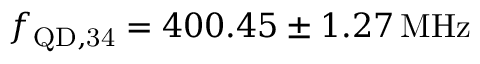<formula> <loc_0><loc_0><loc_500><loc_500>f _ { Q D , 3 4 } = 4 0 0 . 4 5 \pm 1 . 2 7 \, M H z</formula> 